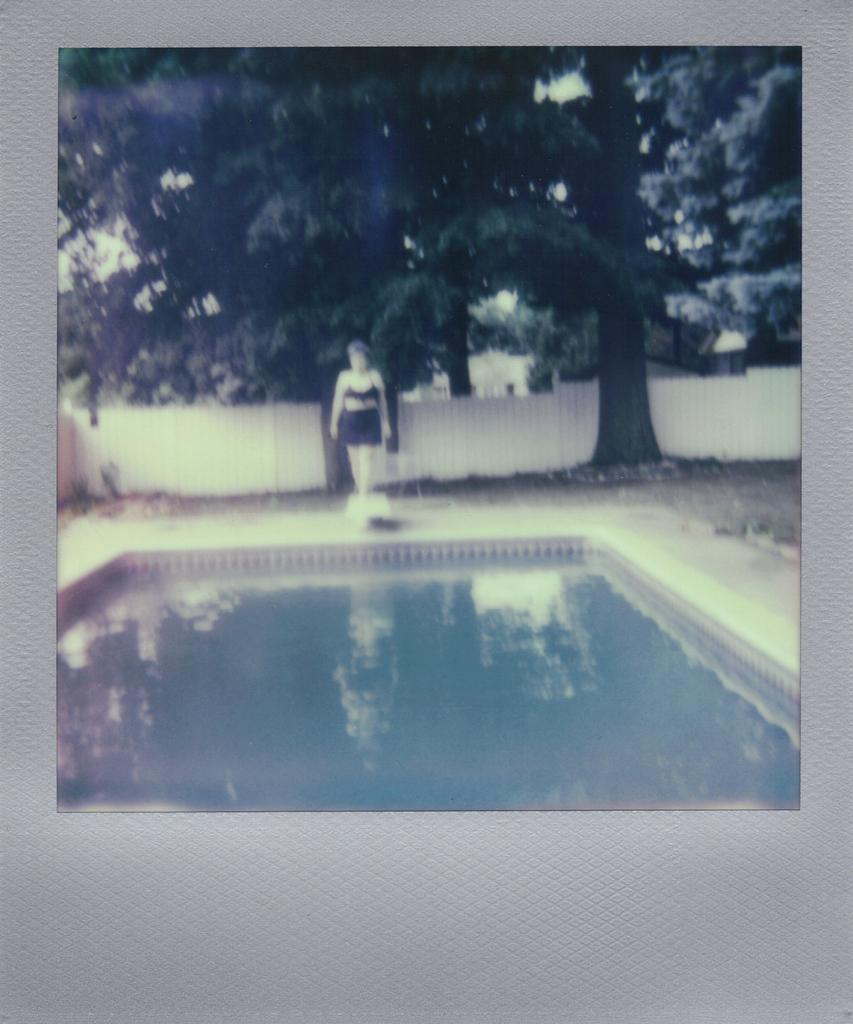What is the main feature in the image? There is a swimming pool in the image. Can you describe the person in the image? There is a lady wearing a black dress in the image. What can be seen in the background of the image? There are trees in the background of the image. What type of fencing is present in the image? There is white color fencing in the image. What degree does the lady in the image hold? There is no information about the lady's degree in the image. What type of thing is the lady holding in the image? The image does not show the lady holding any thing. 